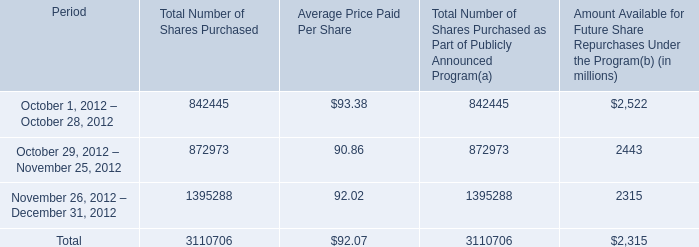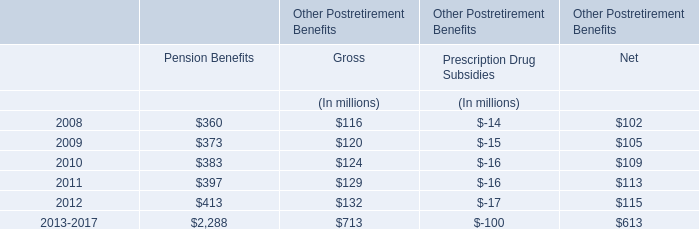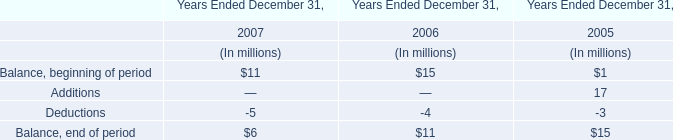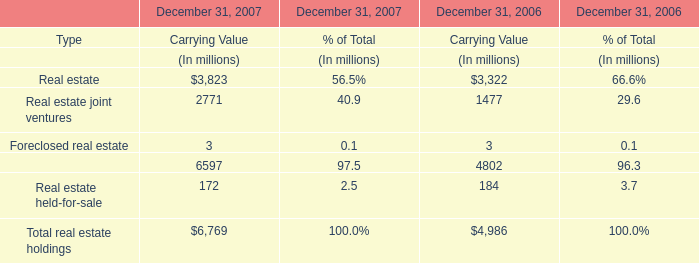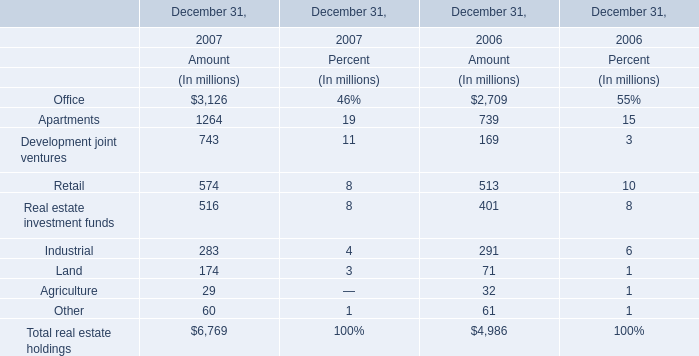Which year is the Carrying Value for Real estate on December 31 greater than 3600 million ? 
Answer: 2007. 